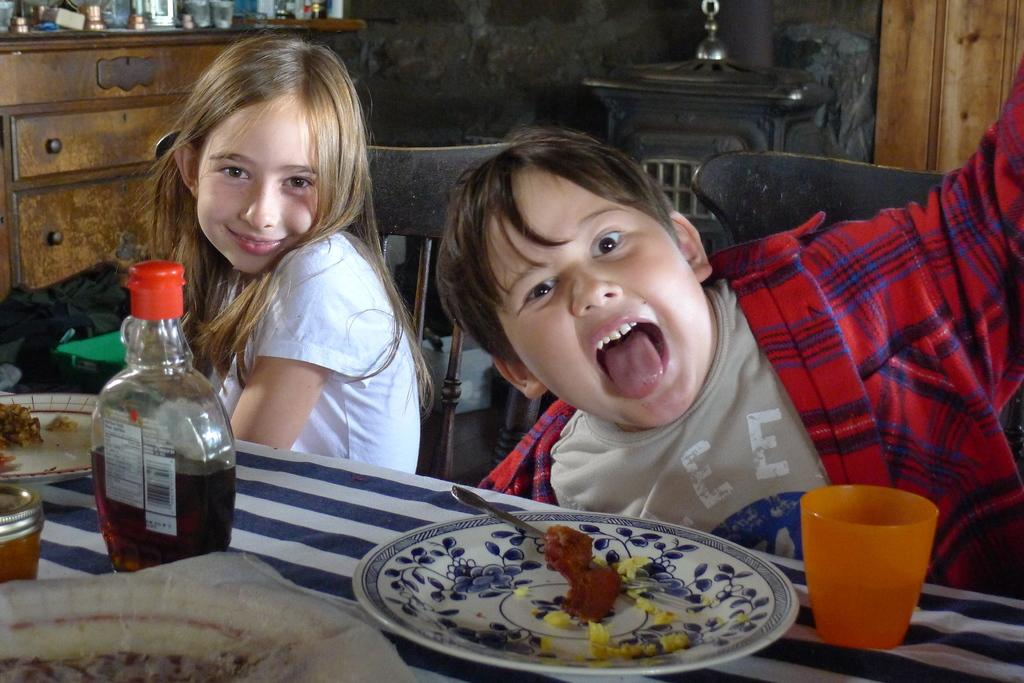How many people are present in the image? There are two people in the image. What type of furniture can be seen in the image? There are cupboards and a table in the image. What items are on the table in the image? There are plates, a glass, and a bottle on the table in the image. What is the income of the people in the image? There is no information about the income of the people in the image. Is there a quilt visible in the image? There is no quilt present in the image. 